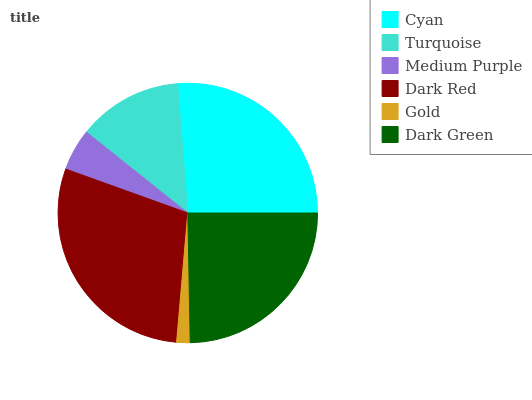Is Gold the minimum?
Answer yes or no. Yes. Is Dark Red the maximum?
Answer yes or no. Yes. Is Turquoise the minimum?
Answer yes or no. No. Is Turquoise the maximum?
Answer yes or no. No. Is Cyan greater than Turquoise?
Answer yes or no. Yes. Is Turquoise less than Cyan?
Answer yes or no. Yes. Is Turquoise greater than Cyan?
Answer yes or no. No. Is Cyan less than Turquoise?
Answer yes or no. No. Is Dark Green the high median?
Answer yes or no. Yes. Is Turquoise the low median?
Answer yes or no. Yes. Is Gold the high median?
Answer yes or no. No. Is Gold the low median?
Answer yes or no. No. 